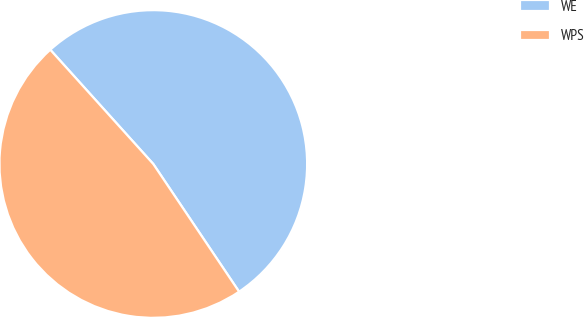<chart> <loc_0><loc_0><loc_500><loc_500><pie_chart><fcel>WE<fcel>WPS<nl><fcel>52.26%<fcel>47.74%<nl></chart> 